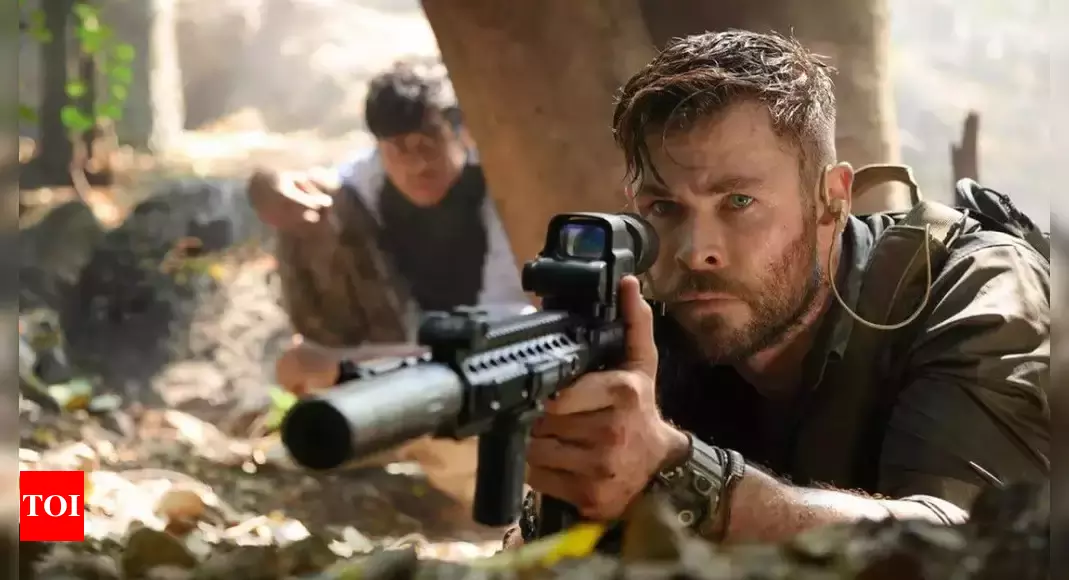What is the significance of the weaponry used by the characters in this image? The weaponry in this image, particularly the rifles with scopes, indicates a high level of preparedness and training. The choice of weapon emphasizes the serious nature of their mission and the potential for close and long-range combat. The presence of such sophisticated weaponry suggests that the characters are either military or specialized operatives, adding layers to their backstory and the gravity of their mission. This equipment not only enhances their capability to remain hidden but also indicates that they are ready to engage in tactical combat scenarios. 